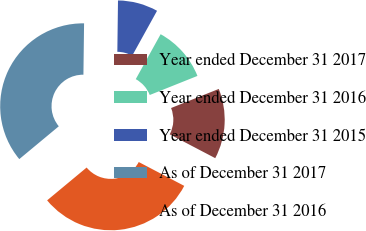Convert chart to OTSL. <chart><loc_0><loc_0><loc_500><loc_500><pie_chart><fcel>Year ended December 31 2017<fcel>Year ended December 31 2016<fcel>Year ended December 31 2015<fcel>As of December 31 2017<fcel>As of December 31 2016<nl><fcel>13.74%<fcel>10.9%<fcel>7.84%<fcel>36.24%<fcel>31.29%<nl></chart> 